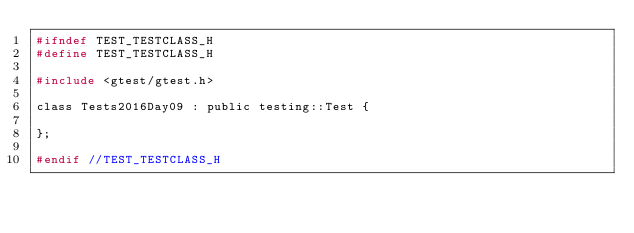Convert code to text. <code><loc_0><loc_0><loc_500><loc_500><_C_>#ifndef TEST_TESTCLASS_H
#define TEST_TESTCLASS_H

#include <gtest/gtest.h>

class Tests2016Day09 : public testing::Test {

};

#endif //TEST_TESTCLASS_H
</code> 